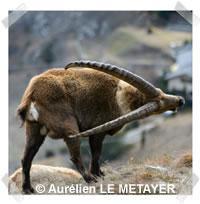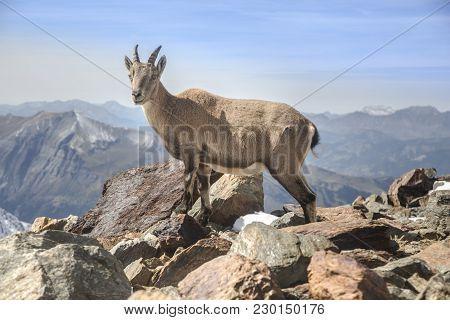The first image is the image on the left, the second image is the image on the right. Examine the images to the left and right. Is the description "The left and right image contains a total of two pairs of fight goat." accurate? Answer yes or no. No. The first image is the image on the left, the second image is the image on the right. Examine the images to the left and right. Is the description "There are two Ibex Rams standing on greenery." accurate? Answer yes or no. No. 